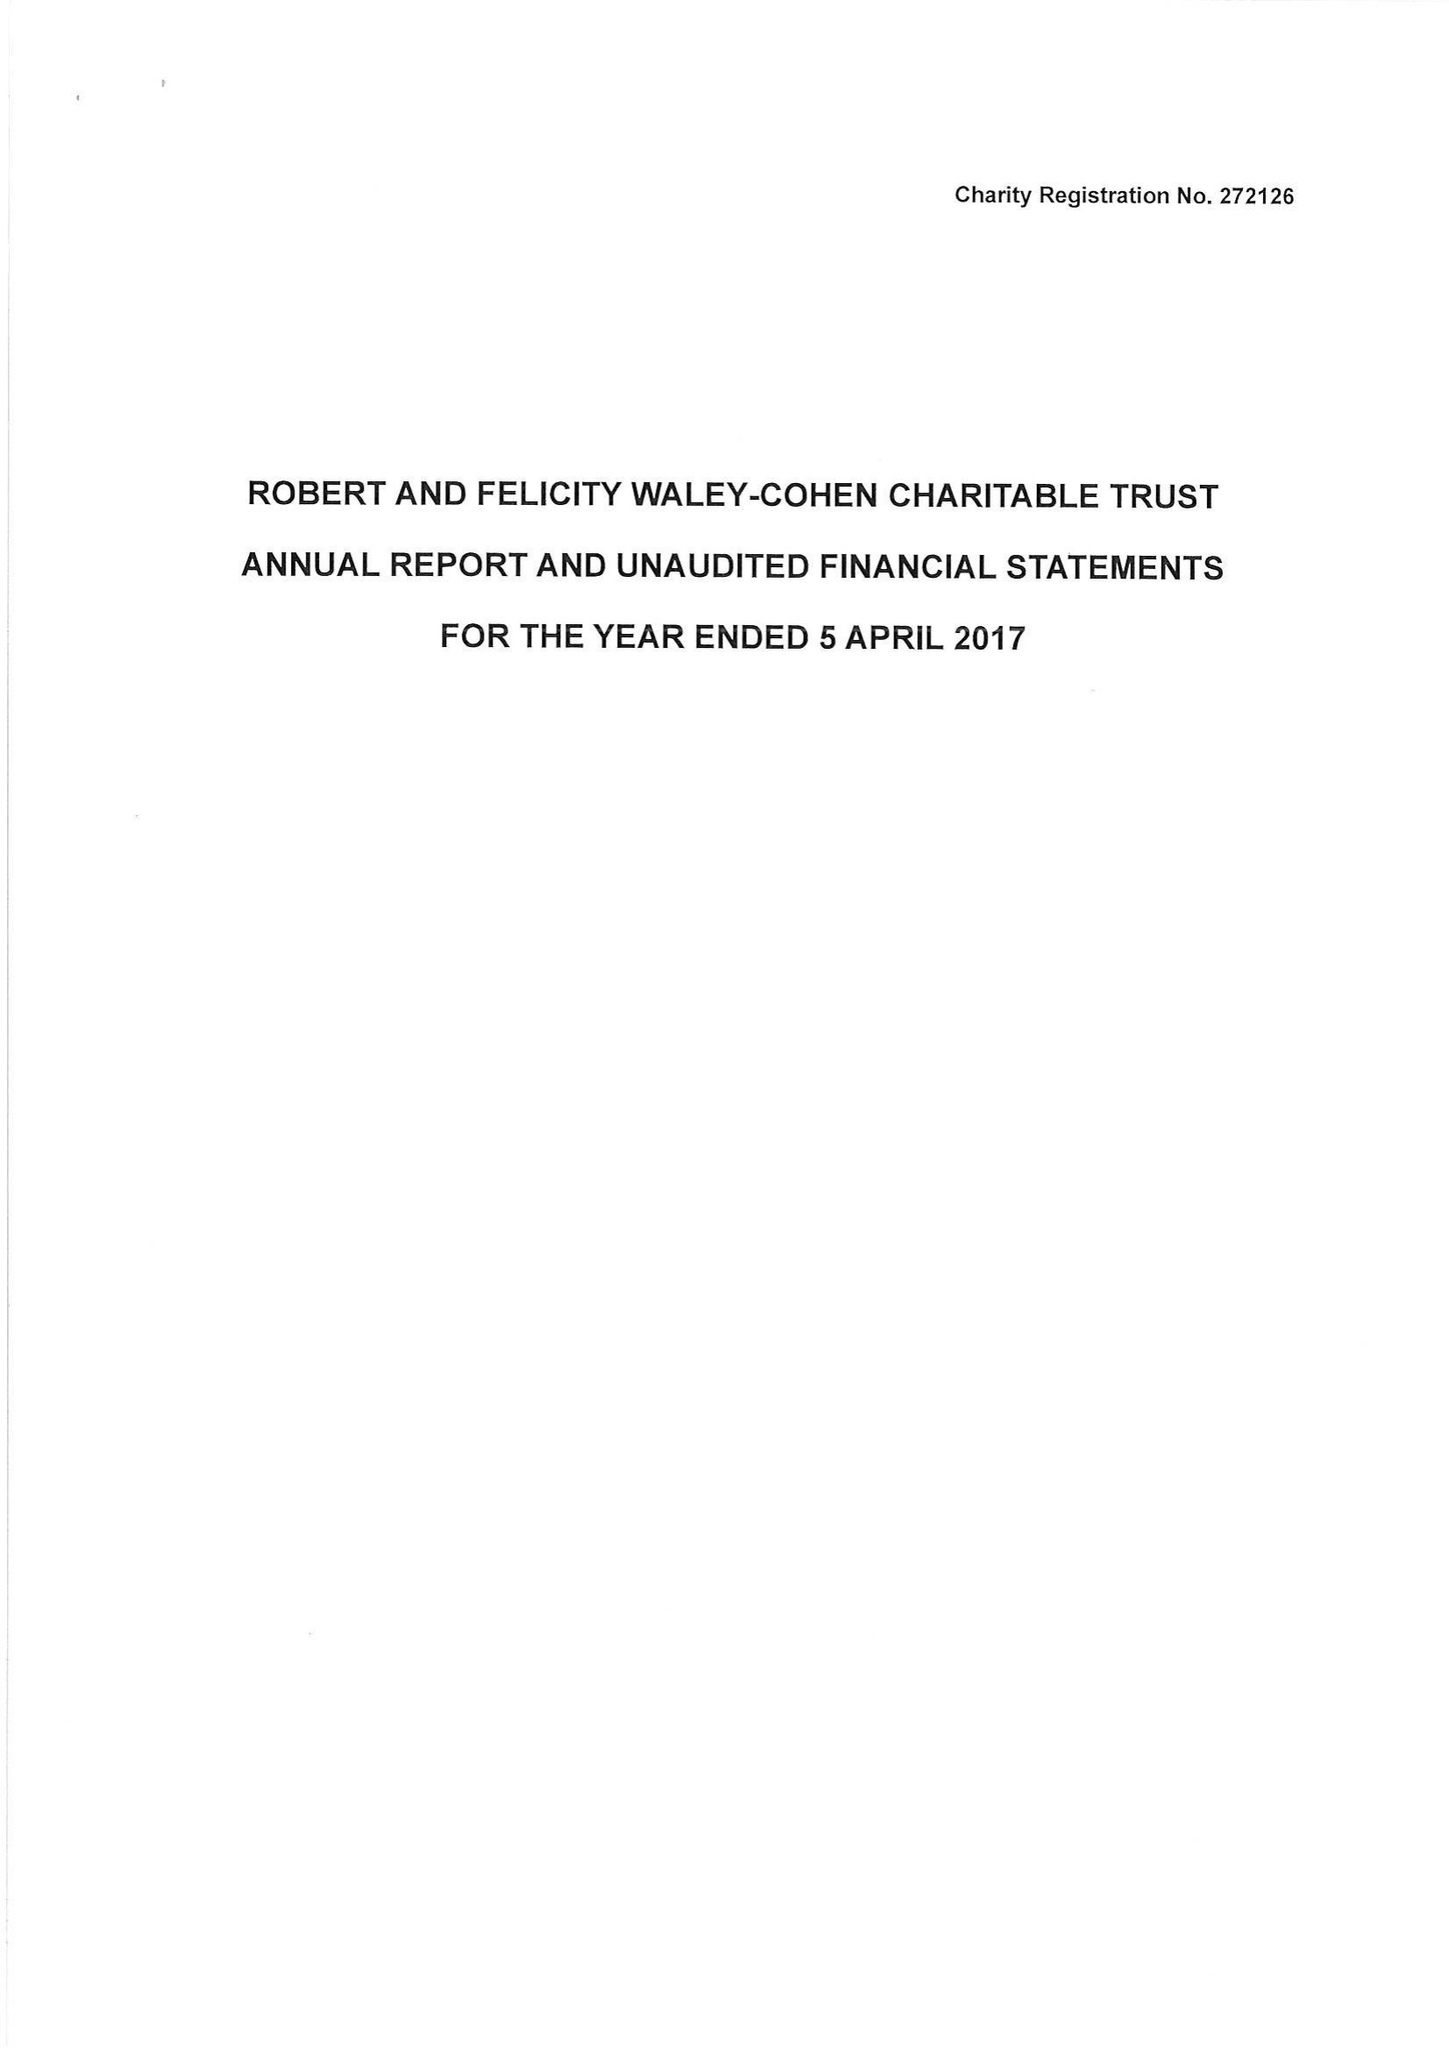What is the value for the spending_annually_in_british_pounds?
Answer the question using a single word or phrase. 140315.00 